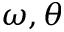Convert formula to latex. <formula><loc_0><loc_0><loc_500><loc_500>\omega , \theta</formula> 